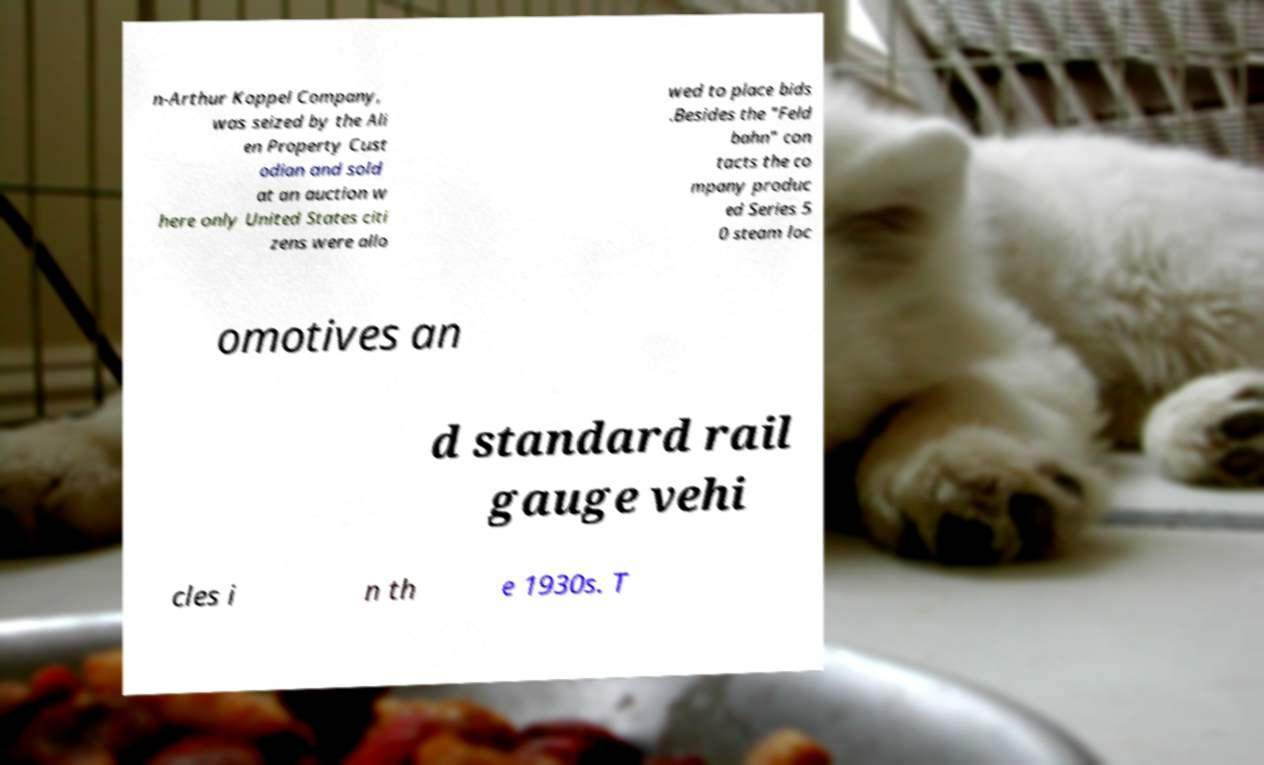Could you extract and type out the text from this image? n-Arthur Koppel Company, was seized by the Ali en Property Cust odian and sold at an auction w here only United States citi zens were allo wed to place bids .Besides the "Feld bahn" con tacts the co mpany produc ed Series 5 0 steam loc omotives an d standard rail gauge vehi cles i n th e 1930s. T 